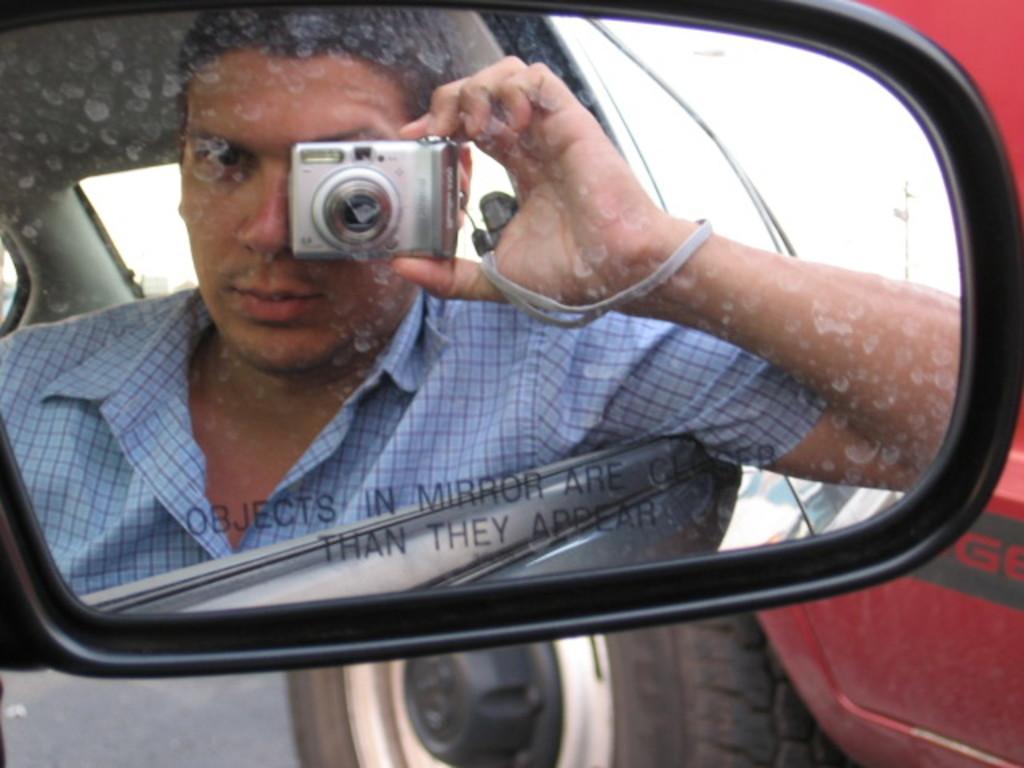Please provide a concise description of this image. In the image there is a mirror we an see a person reflecting in the mirror. He is holding a camera. 